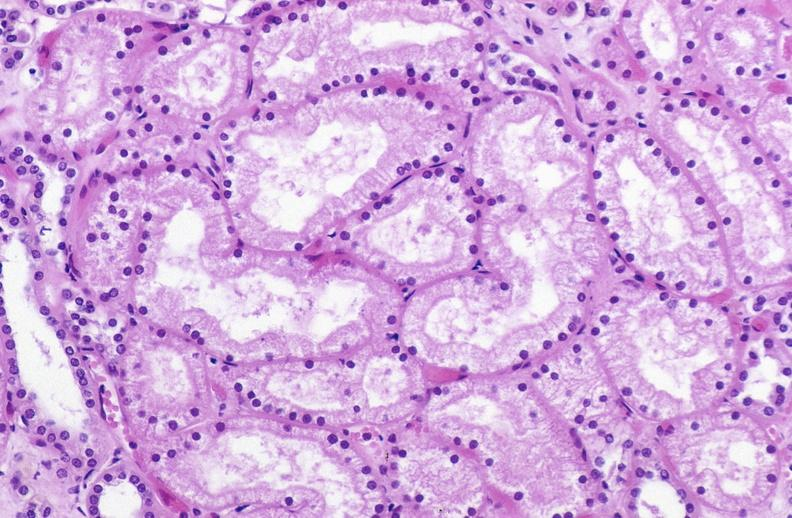what does this image show?
Answer the question using a single word or phrase. Atn acute tubular necrosis 